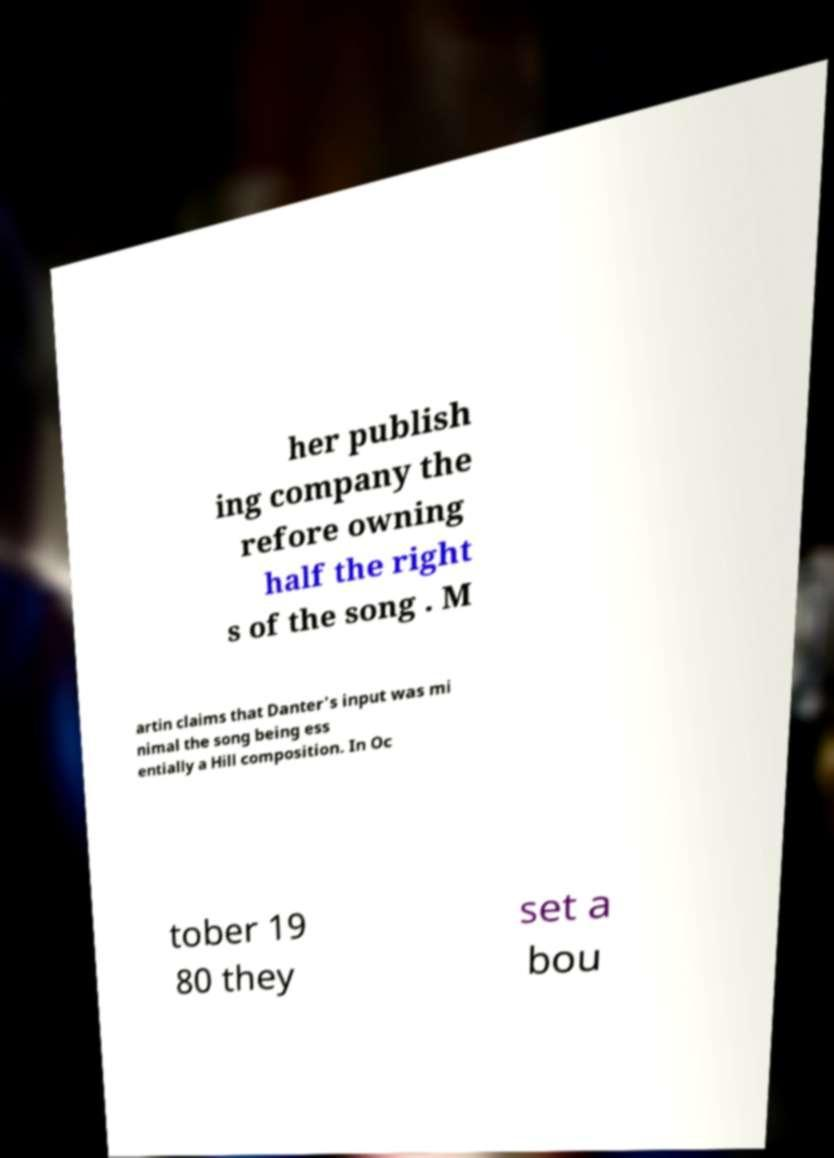Can you accurately transcribe the text from the provided image for me? her publish ing company the refore owning half the right s of the song . M artin claims that Danter's input was mi nimal the song being ess entially a Hill composition. In Oc tober 19 80 they set a bou 